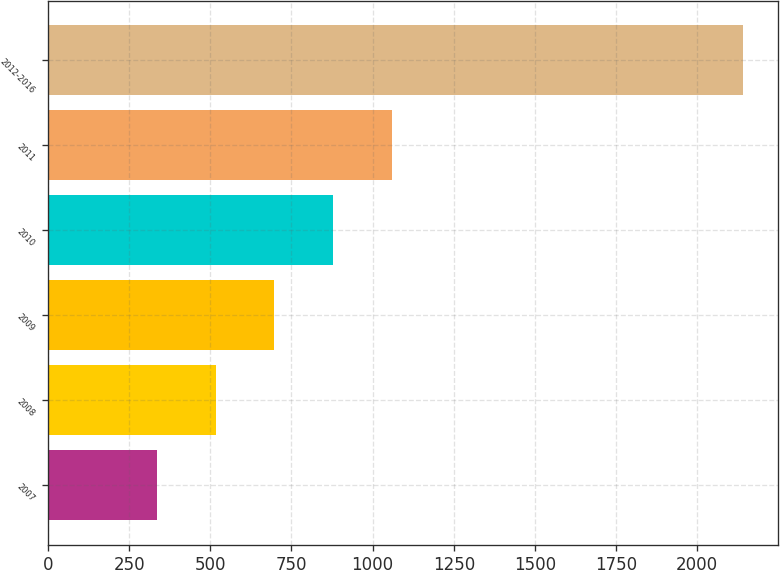Convert chart. <chart><loc_0><loc_0><loc_500><loc_500><bar_chart><fcel>2007<fcel>2008<fcel>2009<fcel>2010<fcel>2011<fcel>2012-2016<nl><fcel>337<fcel>517.4<fcel>697.8<fcel>878.2<fcel>1058.6<fcel>2141<nl></chart> 